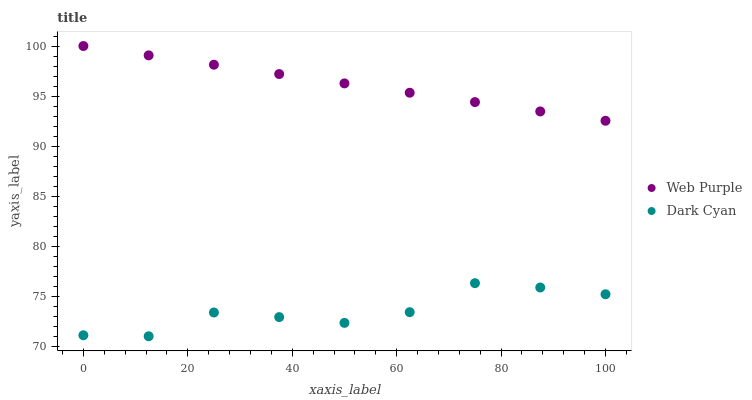Does Dark Cyan have the minimum area under the curve?
Answer yes or no. Yes. Does Web Purple have the maximum area under the curve?
Answer yes or no. Yes. Does Web Purple have the minimum area under the curve?
Answer yes or no. No. Is Web Purple the smoothest?
Answer yes or no. Yes. Is Dark Cyan the roughest?
Answer yes or no. Yes. Is Web Purple the roughest?
Answer yes or no. No. Does Dark Cyan have the lowest value?
Answer yes or no. Yes. Does Web Purple have the lowest value?
Answer yes or no. No. Does Web Purple have the highest value?
Answer yes or no. Yes. Is Dark Cyan less than Web Purple?
Answer yes or no. Yes. Is Web Purple greater than Dark Cyan?
Answer yes or no. Yes. Does Dark Cyan intersect Web Purple?
Answer yes or no. No. 